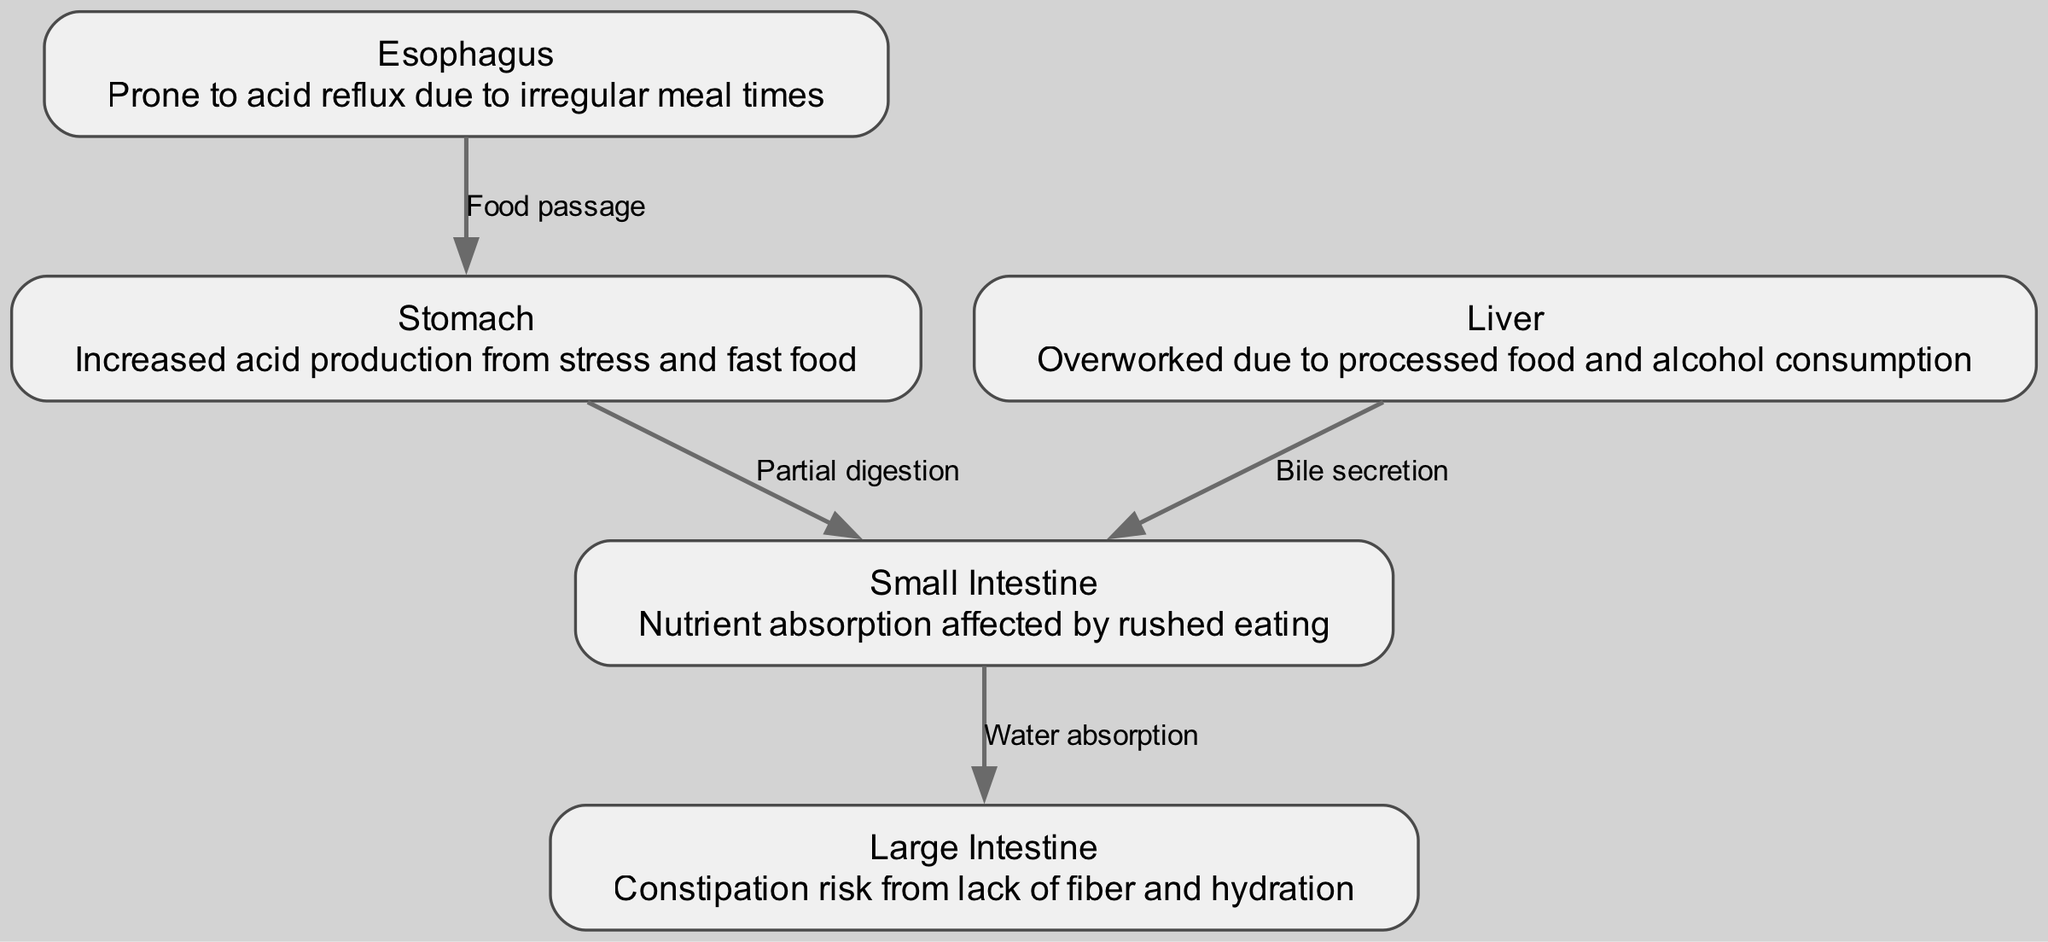What is the first organ in the digestive system? The diagram shows that food enters the digestive system through the esophagus. Since esophagus is the starting point and the first organ mentioned, it is identified as the first organ in the digestive system.
Answer: Esophagus How many nodes are there in the diagram? The diagram lists five distinct organs, each represented as a node: esophagus, stomach, small intestine, large intestine, and liver. Counting these gives a total of five nodes in the diagram.
Answer: 5 What is the relationship between the stomach and the small intestine? The diagram indicates that food moves from the stomach to the small intestine following the process of partial digestion. This directed flow establishes the relationship between the two organs.
Answer: Partial digestion What issue is the liver prone to due to lifestyle factors? The description associated with the liver states it is "Overworked due to processed food and alcohol consumption," highlighting a common issue related to fast-paced lifestyles.
Answer: Overworked What risk is associated with the large intestine due to irregular eating habits? The large intestine is described as being at risk of "Constipation" from a lack of fiber and hydration, a direct correlation to poor eating habits. This establishes a health concern linked to dietary choices.
Answer: Constipation How does food travel from the small intestine to the large intestine? The diagram specifies that the connection between these two organs involves the process of "Water absorption," which indicates the flow from the small intestine to the large intestine.
Answer: Water absorption What nutritional process occurs in the small intestine that can be affected by rushed eating? The small intestine is noted for its role in "Nutrient absorption," which can be negatively impacted by the act of eating too quickly. It signifies how eating habits can disrupt proper digestion and nutrient intake.
Answer: Nutrient absorption What does the liver secrete into the small intestine? According to the diagram, the liver has a directed connection to the small intestine for "Bile secretion," indicating its role in the digestive process.
Answer: Bile secretion 